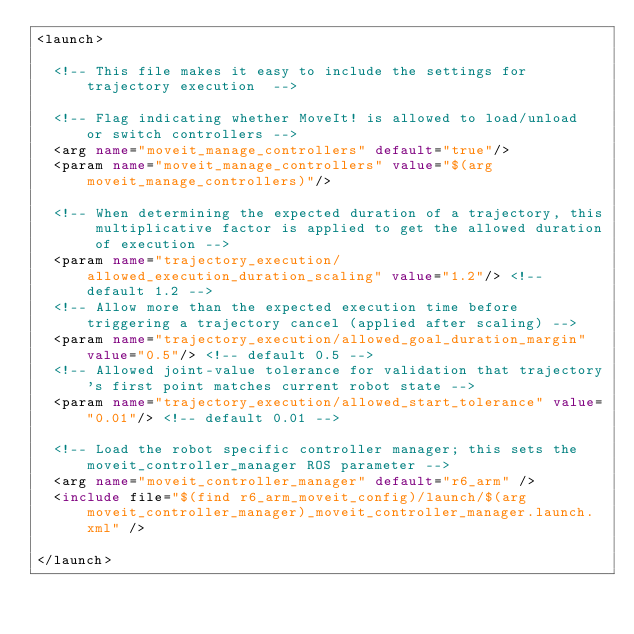Convert code to text. <code><loc_0><loc_0><loc_500><loc_500><_XML_><launch>

  <!-- This file makes it easy to include the settings for trajectory execution  -->

  <!-- Flag indicating whether MoveIt! is allowed to load/unload  or switch controllers -->
  <arg name="moveit_manage_controllers" default="true"/>
  <param name="moveit_manage_controllers" value="$(arg moveit_manage_controllers)"/>

  <!-- When determining the expected duration of a trajectory, this multiplicative factor is applied to get the allowed duration of execution -->
  <param name="trajectory_execution/allowed_execution_duration_scaling" value="1.2"/> <!-- default 1.2 -->
  <!-- Allow more than the expected execution time before triggering a trajectory cancel (applied after scaling) -->
  <param name="trajectory_execution/allowed_goal_duration_margin" value="0.5"/> <!-- default 0.5 -->
  <!-- Allowed joint-value tolerance for validation that trajectory's first point matches current robot state -->
  <param name="trajectory_execution/allowed_start_tolerance" value="0.01"/> <!-- default 0.01 -->

  <!-- Load the robot specific controller manager; this sets the moveit_controller_manager ROS parameter -->
  <arg name="moveit_controller_manager" default="r6_arm" />
  <include file="$(find r6_arm_moveit_config)/launch/$(arg moveit_controller_manager)_moveit_controller_manager.launch.xml" />

</launch>
</code> 